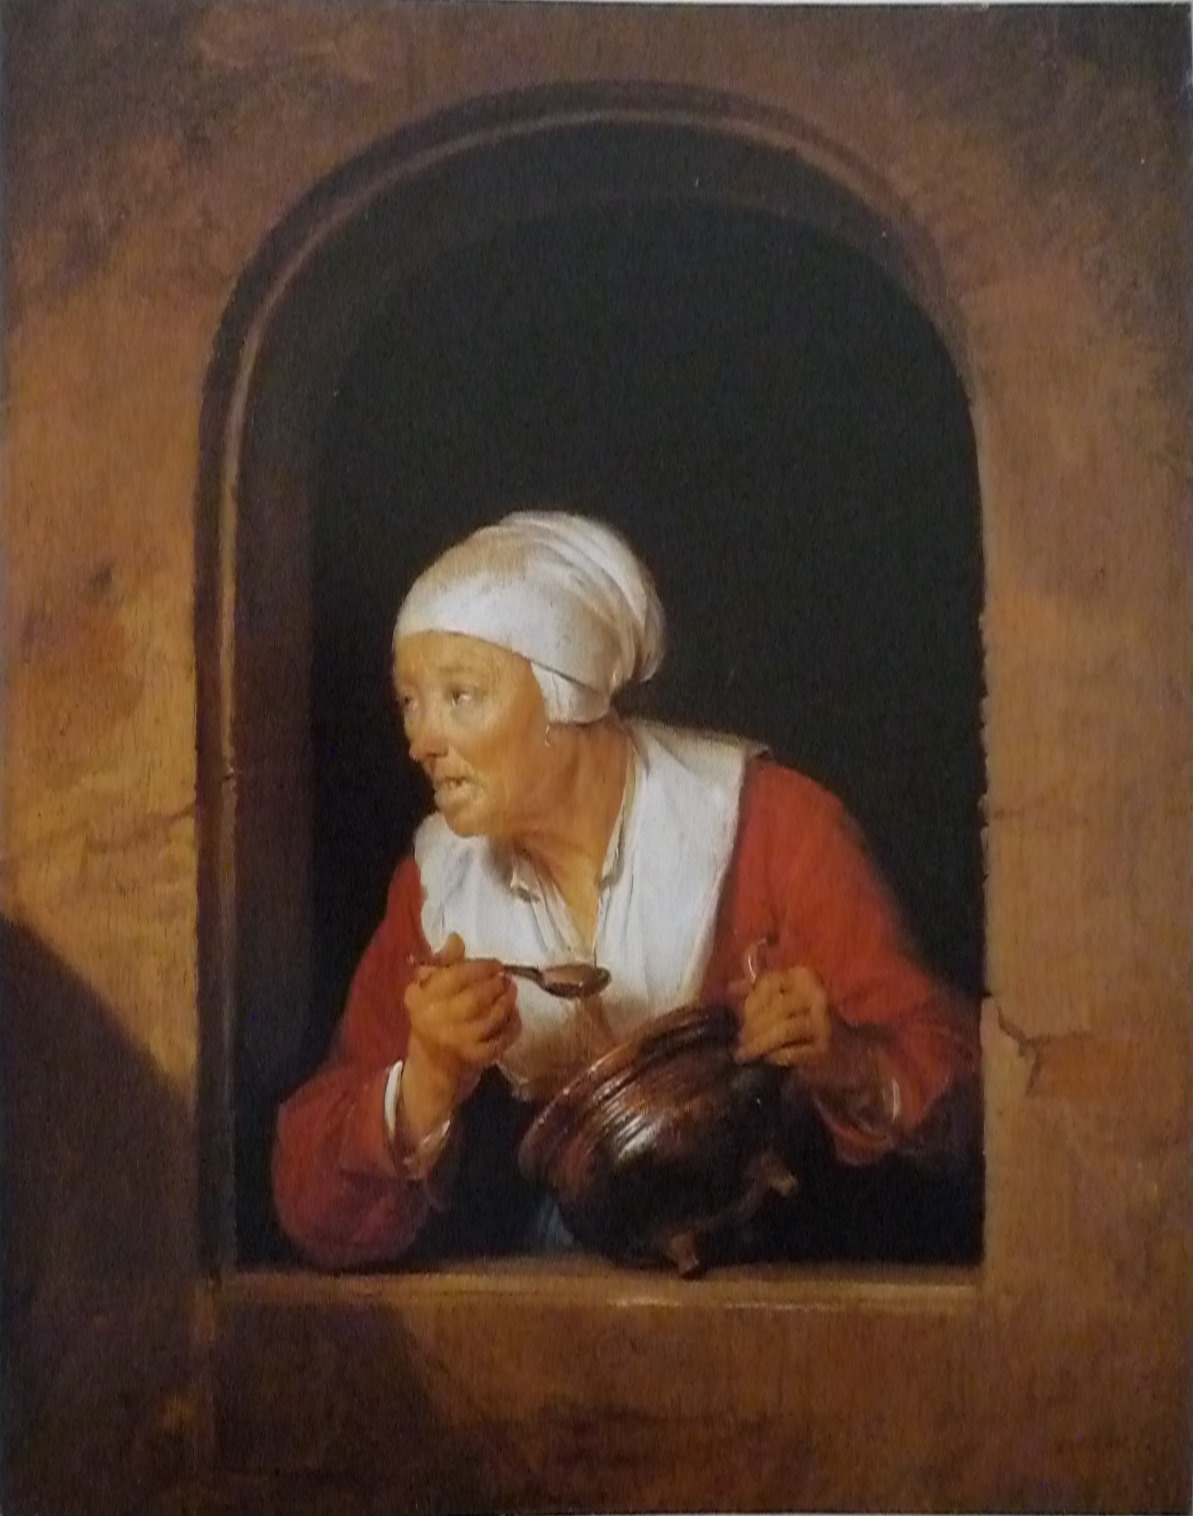Can you provide insight into what the woman's expression might convey? The woman's expression, marked by raised eyebrows, wide-open eyes, and a slightly open mouth, suggests a mix of surprise and concentration. It's as if she's been caught off-guard by an unexpected visitor or event, yet her gaze implies a focused attention, possibly indicating that she's intently listening or trying to comprehend the situation unfolding before her. 